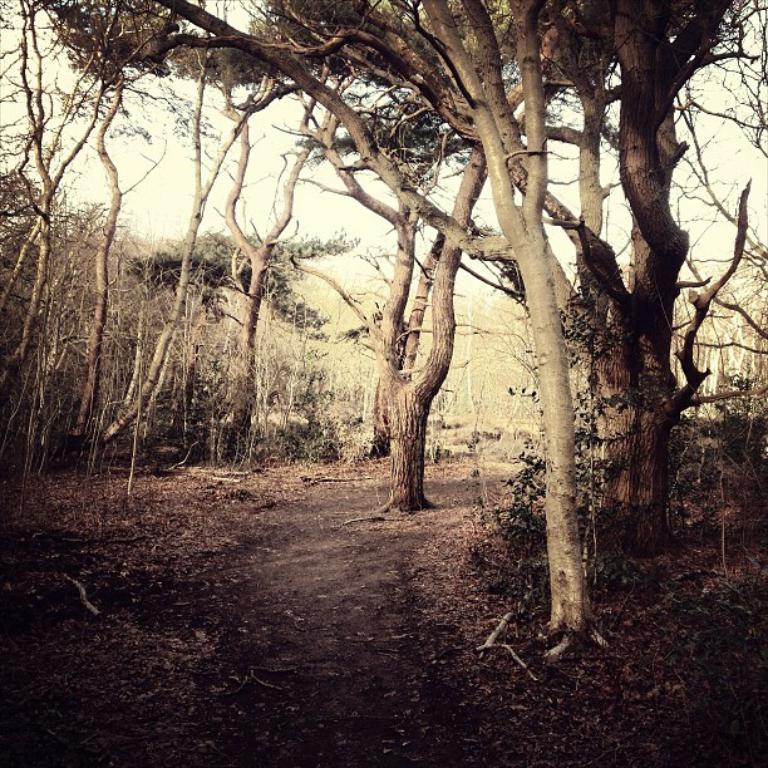What can be seen on the ground in the image? There are dried leaves and sticks on the ground in the image. What is visible in the background of the image? There are many trees and the sky in the background of the image. What type of roof can be seen on the trees in the image? There are no roofs present in the image, as it features trees in the background. What kind of loaf is being used to hold the dried leaves in the image? There is no loaf present in the image; it features dried leaves and sticks on the ground. 